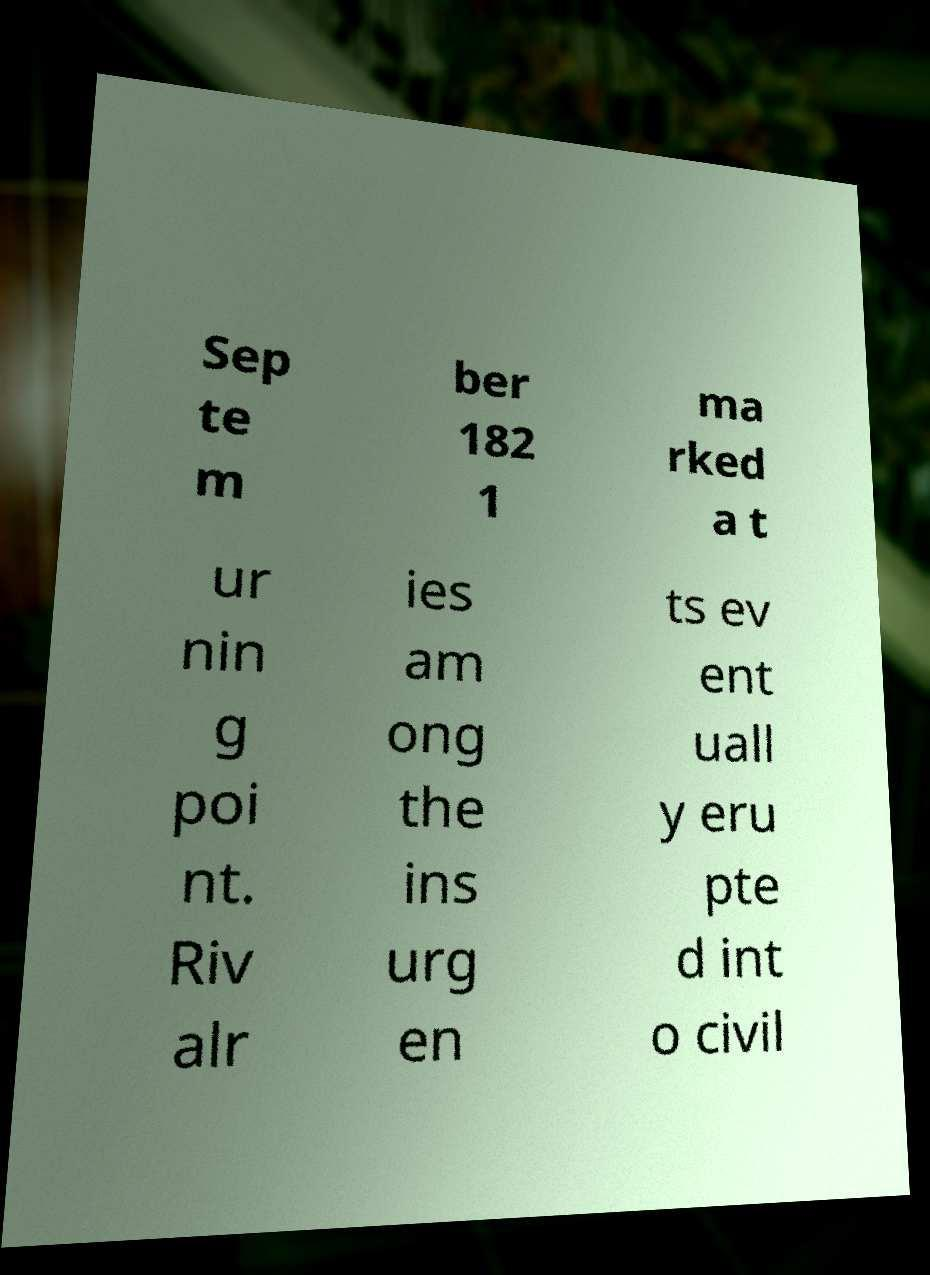Please identify and transcribe the text found in this image. Sep te m ber 182 1 ma rked a t ur nin g poi nt. Riv alr ies am ong the ins urg en ts ev ent uall y eru pte d int o civil 